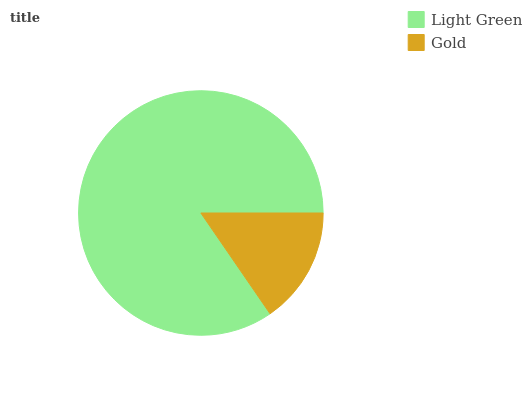Is Gold the minimum?
Answer yes or no. Yes. Is Light Green the maximum?
Answer yes or no. Yes. Is Gold the maximum?
Answer yes or no. No. Is Light Green greater than Gold?
Answer yes or no. Yes. Is Gold less than Light Green?
Answer yes or no. Yes. Is Gold greater than Light Green?
Answer yes or no. No. Is Light Green less than Gold?
Answer yes or no. No. Is Light Green the high median?
Answer yes or no. Yes. Is Gold the low median?
Answer yes or no. Yes. Is Gold the high median?
Answer yes or no. No. Is Light Green the low median?
Answer yes or no. No. 